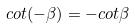Convert formula to latex. <formula><loc_0><loc_0><loc_500><loc_500>c o t ( - \beta ) = - c o t \beta</formula> 